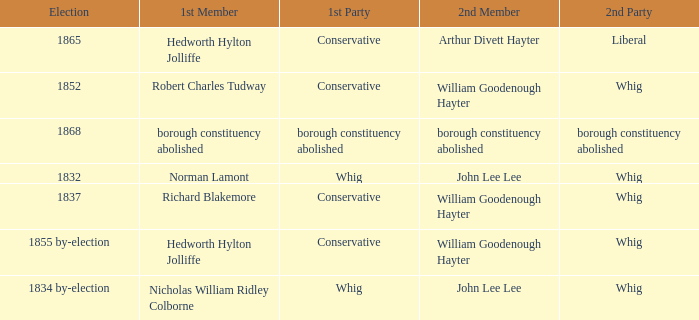What's the party of 2nd member arthur divett hayter when the 1st party is conservative? Liberal. 